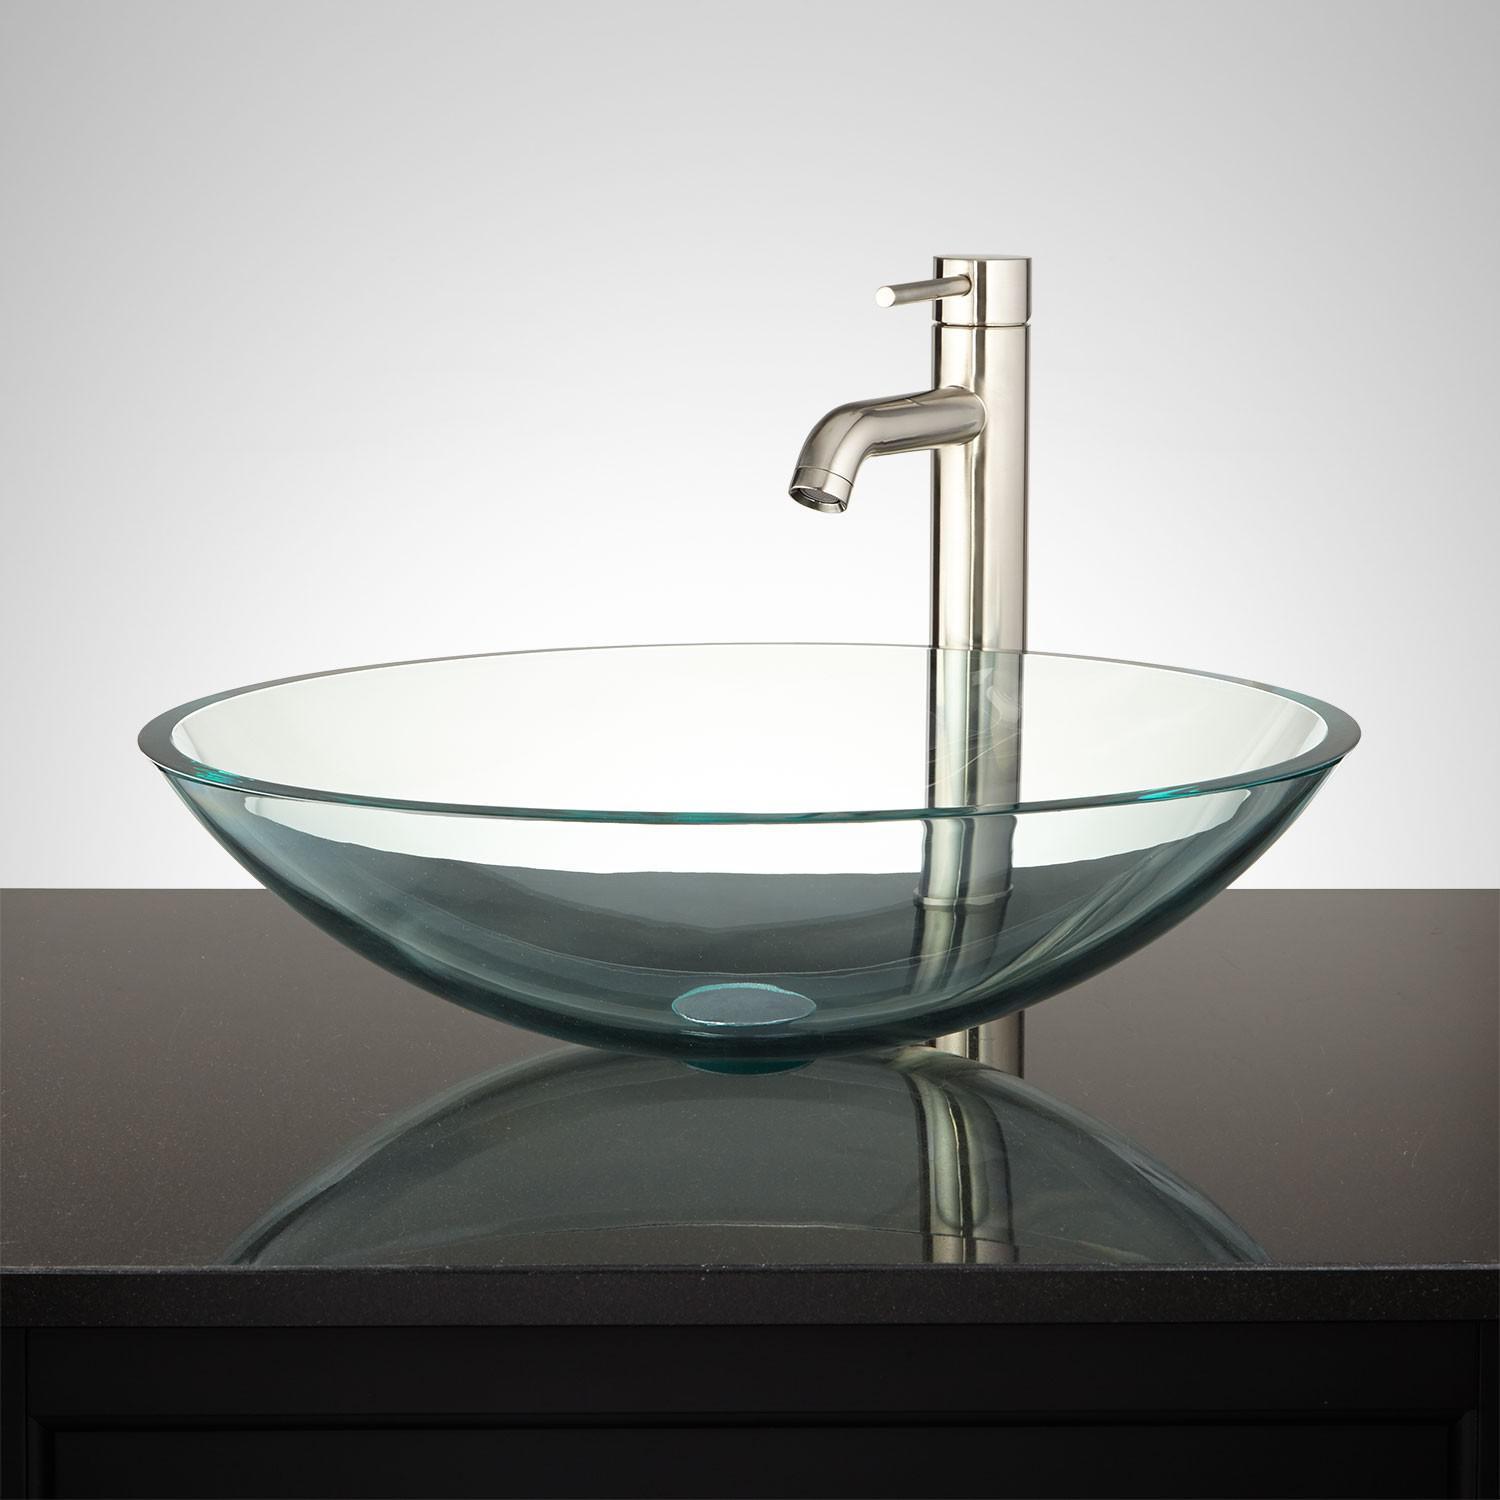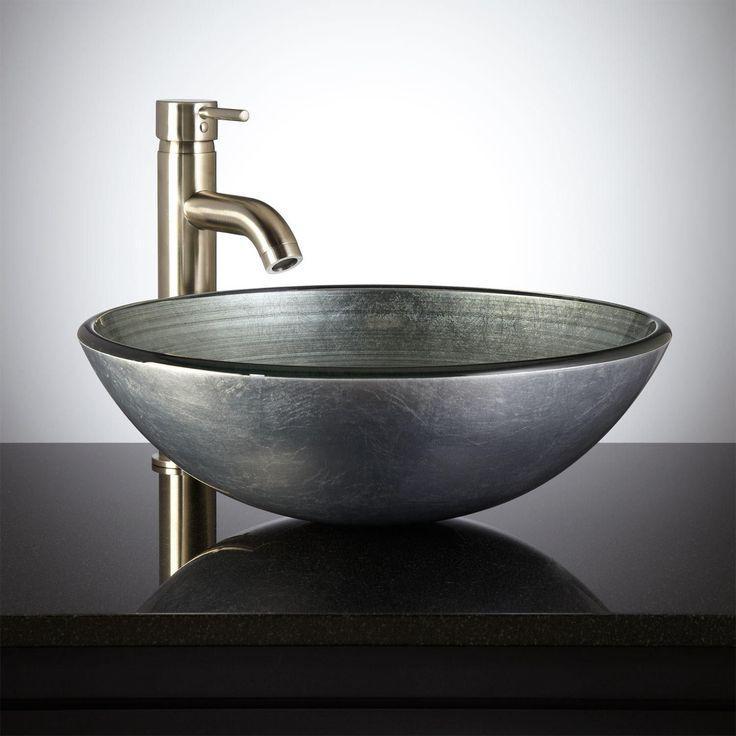The first image is the image on the left, the second image is the image on the right. Evaluate the accuracy of this statement regarding the images: "There is an item next to a sink.". Is it true? Answer yes or no. No. The first image is the image on the left, the second image is the image on the right. Analyze the images presented: Is the assertion "Sinks on the left and right share the same shape and faucet style." valid? Answer yes or no. Yes. 